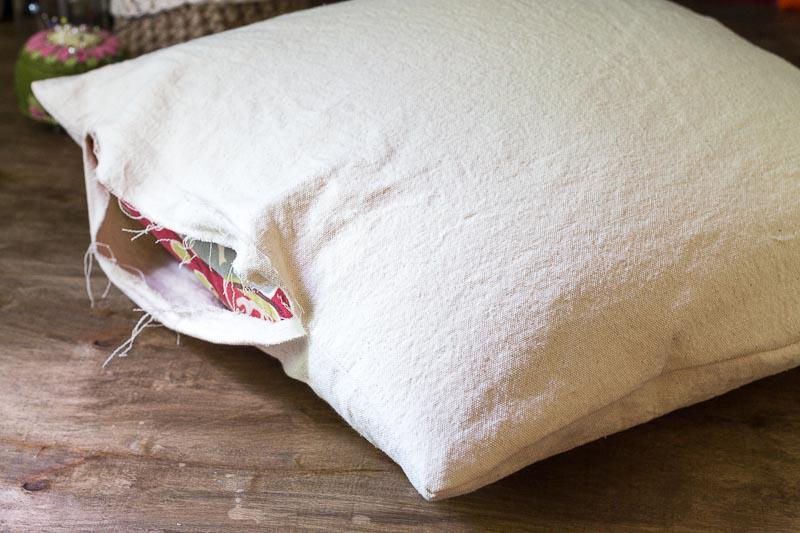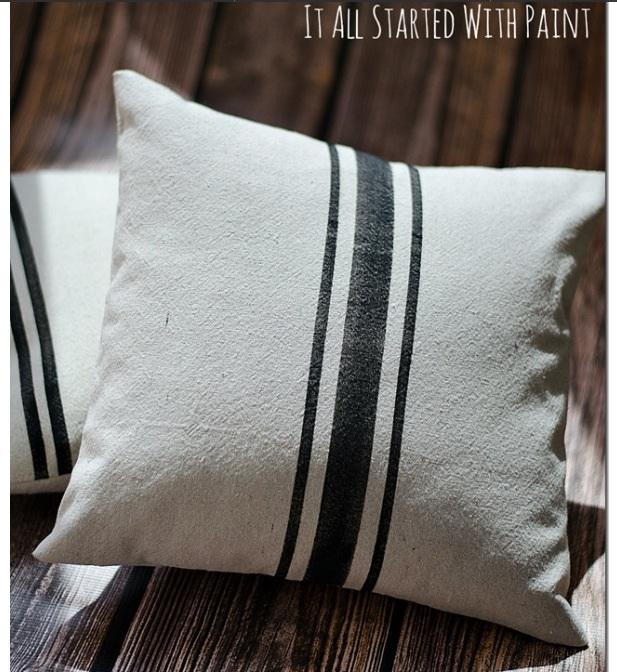The first image is the image on the left, the second image is the image on the right. Evaluate the accuracy of this statement regarding the images: "A square pillow with dark stripes down the middle is overlapping another pillow with stripes and displayed on a woodgrain surface, in the right image.". Is it true? Answer yes or no. Yes. The first image is the image on the left, the second image is the image on the right. Analyze the images presented: Is the assertion "There are two white pillows one in the back with two small strips pattern that repeat itself and a top pillow with 3 strips with the middle being the biggest." valid? Answer yes or no. Yes. 